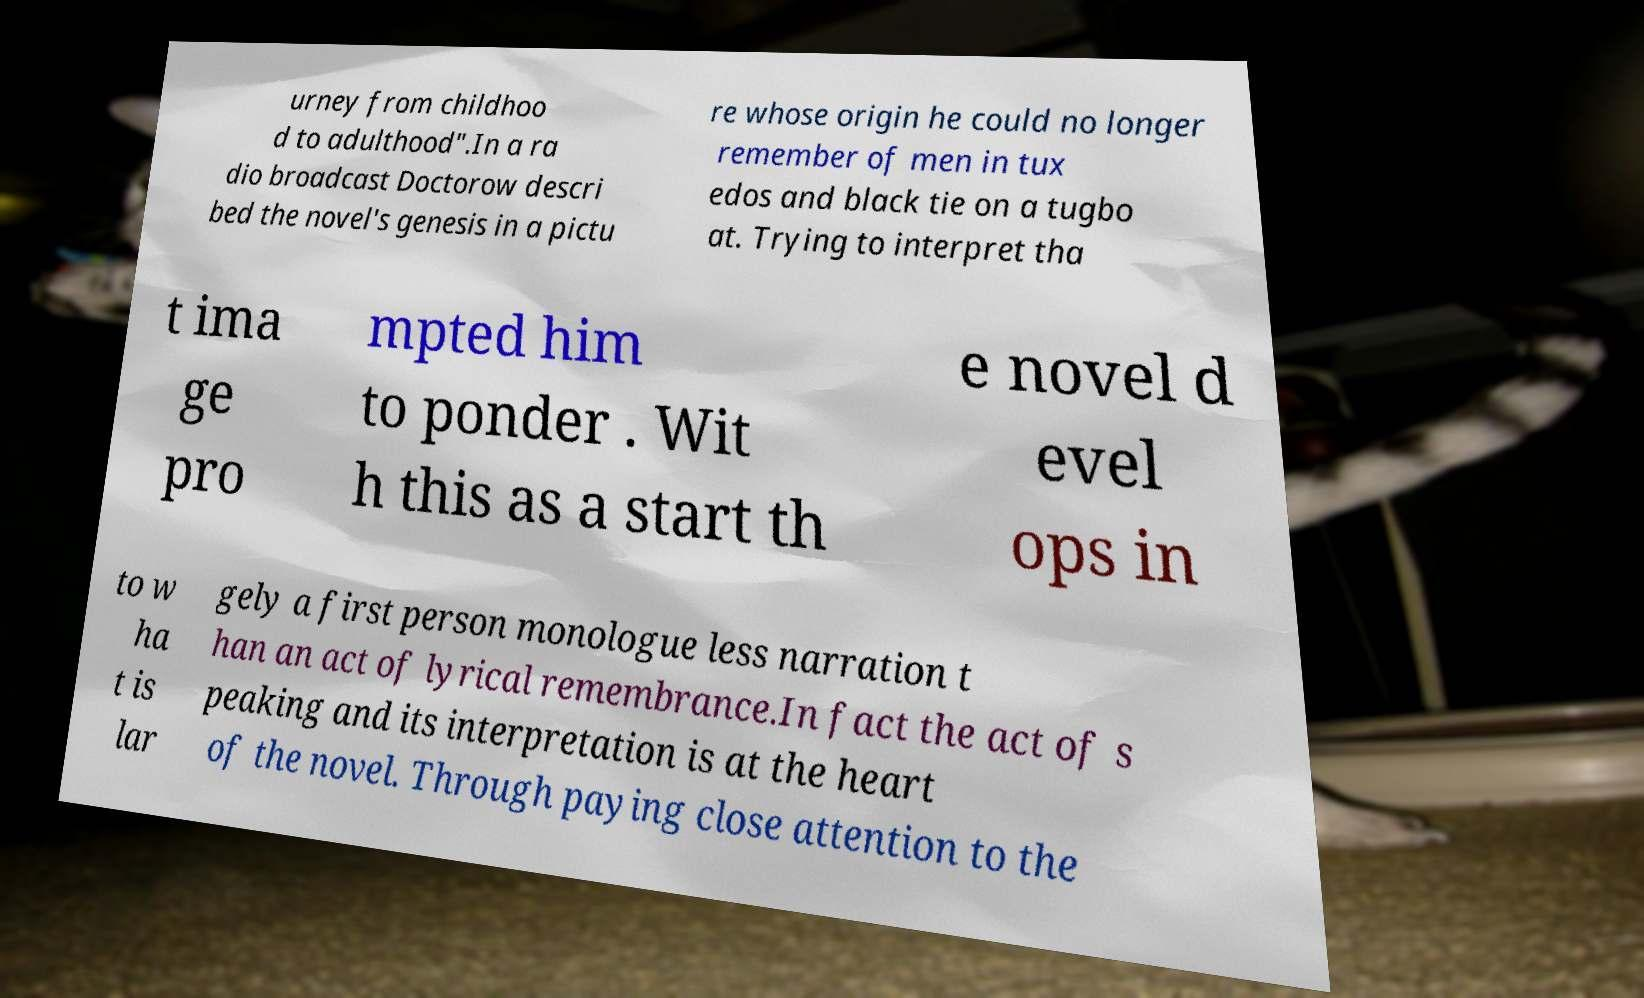Can you read and provide the text displayed in the image?This photo seems to have some interesting text. Can you extract and type it out for me? urney from childhoo d to adulthood".In a ra dio broadcast Doctorow descri bed the novel's genesis in a pictu re whose origin he could no longer remember of men in tux edos and black tie on a tugbo at. Trying to interpret tha t ima ge pro mpted him to ponder . Wit h this as a start th e novel d evel ops in to w ha t is lar gely a first person monologue less narration t han an act of lyrical remembrance.In fact the act of s peaking and its interpretation is at the heart of the novel. Through paying close attention to the 